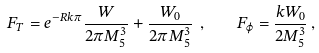<formula> <loc_0><loc_0><loc_500><loc_500>F _ { T } = e ^ { - R k \pi } \frac { W } { 2 \pi M ^ { 3 } _ { 5 } } + \frac { W _ { 0 } } { 2 \pi M ^ { 3 } _ { 5 } } \ , \quad F _ { \varphi } = \frac { k W _ { 0 } } { 2 M ^ { 3 } _ { 5 } } \, ,</formula> 